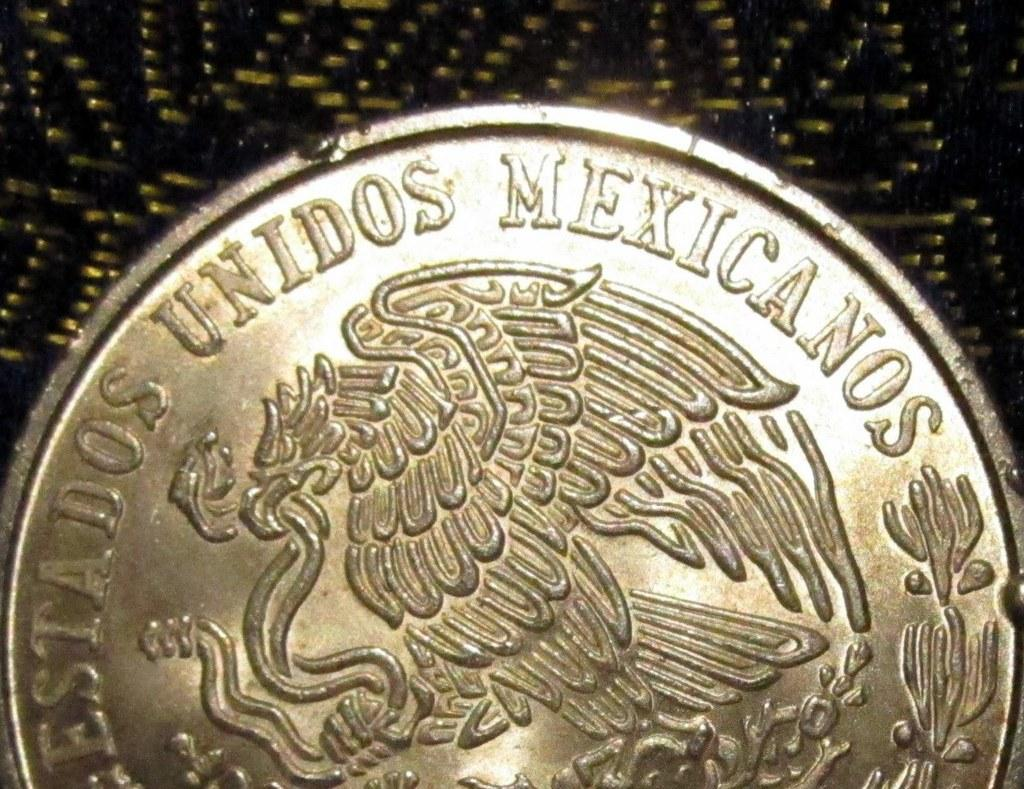<image>
Relay a brief, clear account of the picture shown. a silver coin reading Unidos Mexicanos around the edge 